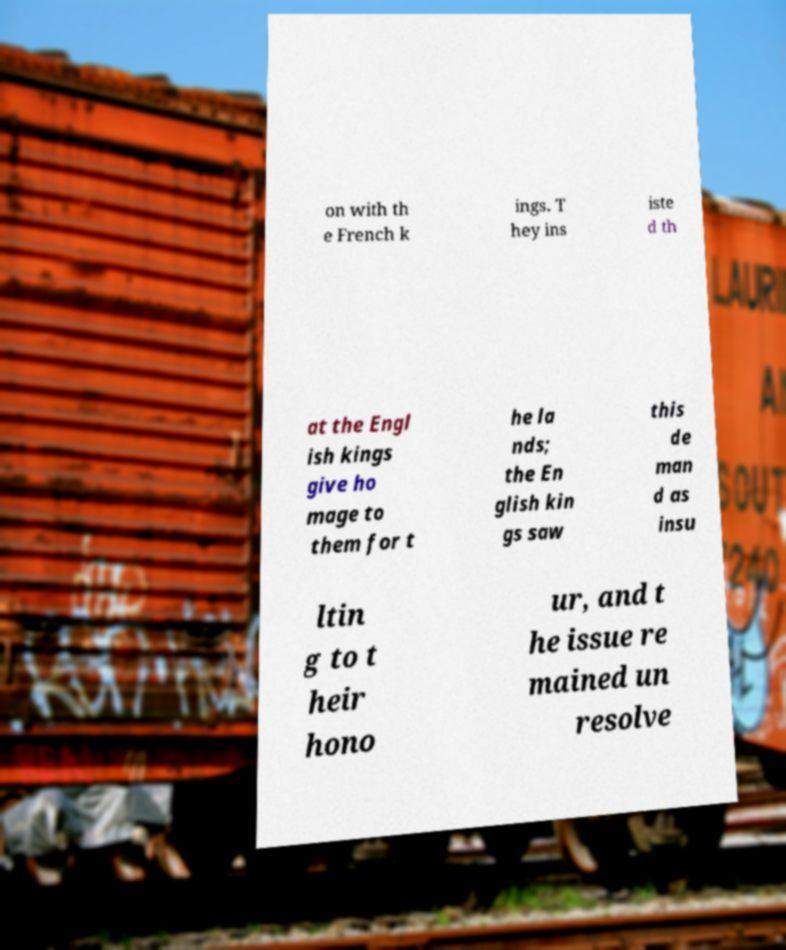I need the written content from this picture converted into text. Can you do that? on with th e French k ings. T hey ins iste d th at the Engl ish kings give ho mage to them for t he la nds; the En glish kin gs saw this de man d as insu ltin g to t heir hono ur, and t he issue re mained un resolve 